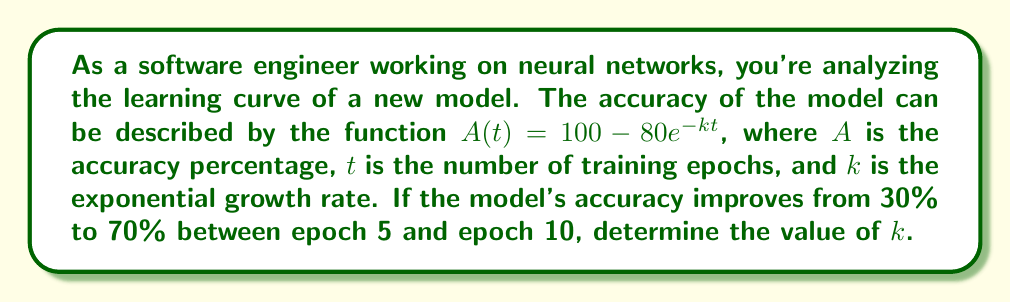Could you help me with this problem? To solve this problem, we'll follow these steps:

1) We have two data points:
   At $t = 5$, $A = 30\%$
   At $t = 10$, $A = 70\%$

2) Let's use the equation for epoch 5:
   $30 = 100 - 80e^{-5k}$
   $80e^{-5k} = 70$
   $e^{-5k} = \frac{70}{80} = \frac{7}{8}$

3) Now for epoch 10:
   $70 = 100 - 80e^{-10k}$
   $80e^{-10k} = 30$
   $e^{-10k} = \frac{30}{80} = \frac{3}{8}$

4) From step 2, we can say:
   $e^{-5k} = (\frac{7}{8})$

5) If we square both sides:
   $(e^{-5k})^2 = (\frac{7}{8})^2$
   $e^{-10k} = \frac{49}{64}$

6) But from step 3, we know that $e^{-10k} = \frac{3}{8}$

7) Therefore:
   $\frac{49}{64} = \frac{3}{8}$

8) Cross-multiply:
   $49 * 8 = 64 * 3$
   $392 = 192$

9) This equality doesn't hold, which means our assumption of an exponential model is not perfect. However, we can still estimate $k$ using either of the equations from steps 2 or 3.

10) Let's use the equation from step 2:
    $e^{-5k} = \frac{7}{8}$
    $-5k = \ln(\frac{7}{8})$
    $k = -\frac{1}{5}\ln(\frac{7}{8})$
    $k \approx 0.0561$
Answer: $k \approx 0.0561$ 